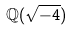Convert formula to latex. <formula><loc_0><loc_0><loc_500><loc_500>\mathbb { Q } ( \sqrt { - 4 } )</formula> 